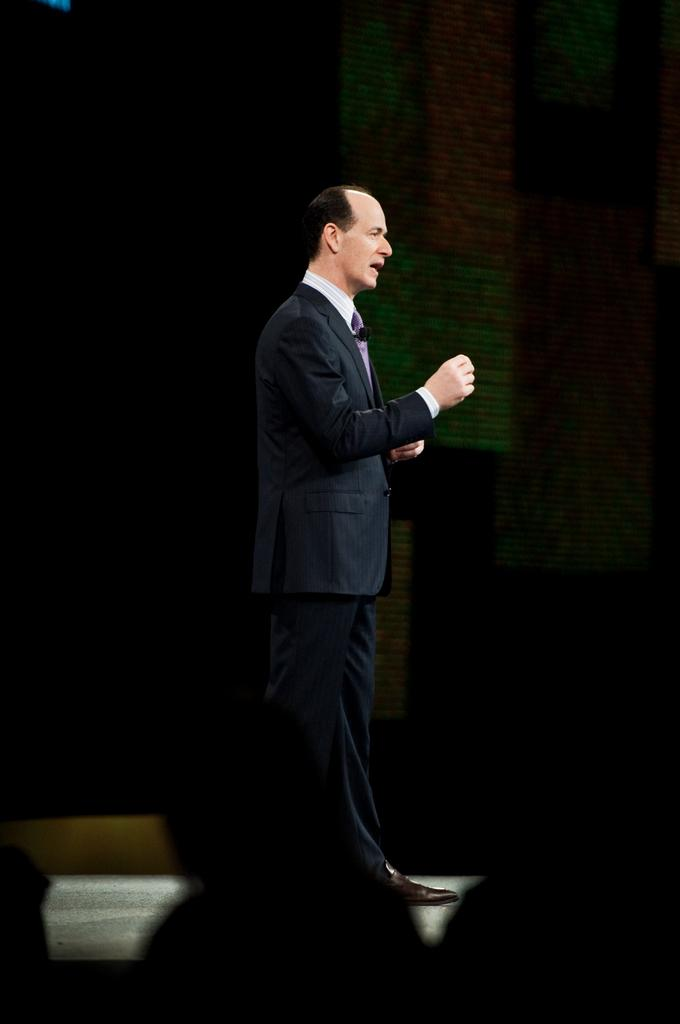What is the main subject of the image? The main subject of the image is a man standing in the middle of the image. What is the man wearing in the image? The man is wearing a coat in the image. Can you describe the background of the image? The background of the image is dark. How many geese are flying in the image? There are no geese present in the image. What type of stitch is being used to sew the man's coat in the image? The image does not provide information about the stitching of the coat, and there is no indication that the coat is being sewn. 